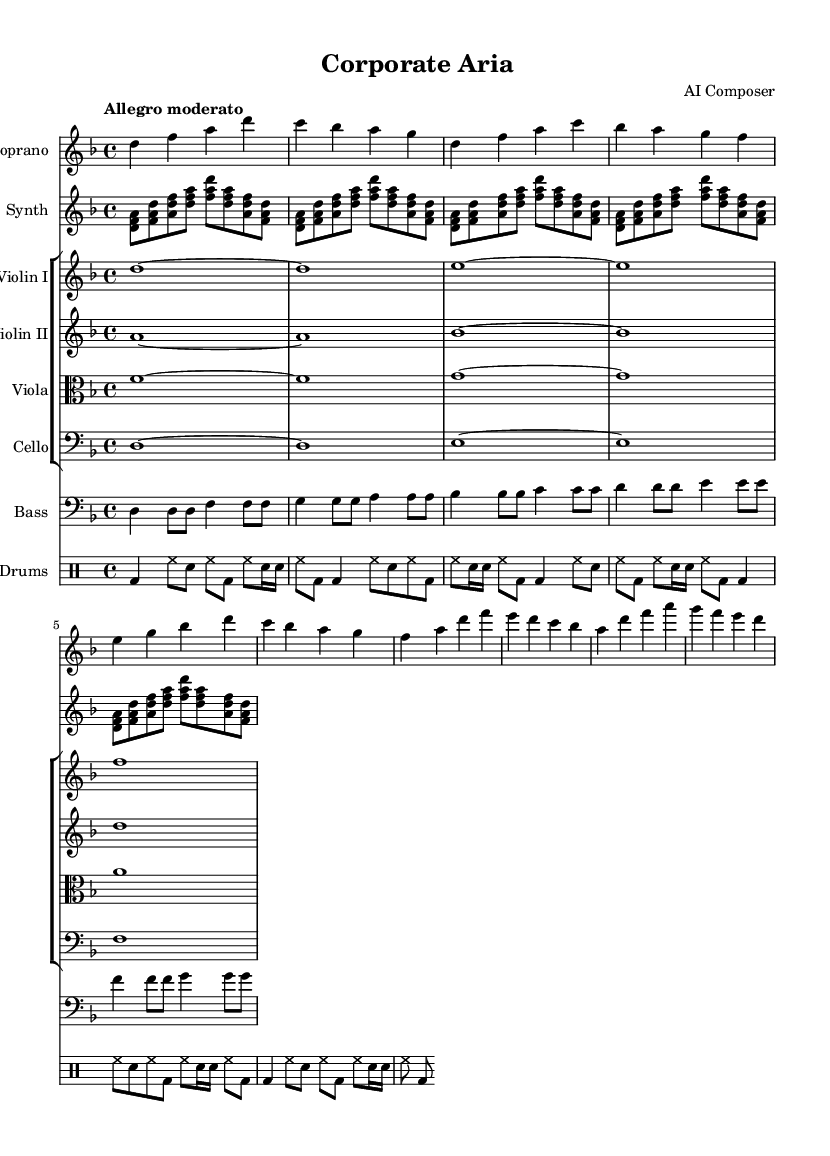What is the key signature of this music? The key signature shows two flats, indicating that the piece is in D minor. The presence of B-flat and E-flat confirms this.
Answer: D minor What is the time signature of the piece? The time signature is indicated at the beginning of the score, showing a four over four, which is common in many musical compositions. This means there are four beats in each measure.
Answer: 4/4 What is the tempo marking for this music? The tempo marking is written as "Allegro moderato," which suggests a moderate pace, typically ranging from 98 to 109 beats per minute.
Answer: Allegro moderato How many measures are there in the soprano part? The soprano part consists of a total of five measures, as indicated by the number of vertical lines separating the measures.
Answer: Five What instrumentation is featured in this piece? The score indicates multiple instruments: soprano, synth, two violins, viola, cello, bass, and drums, showcasing a blend of classical and electronic elements in Fusion opera.
Answer: Soprano, synth, violin I, violin II, viola, cello, bass, drums How does the electronic element integrate with classical instruments? The electronic synth plays rhythmic chords that support the melodic line of the soprano while interacting with traditional strings and percussion, suggesting a modern workplace dynamic within the opera's narrative.
Answer: Fusion of synth and strings What theme does the text of the aria convey? The lyrics illustrate modern workplace emotions and tensions, using imagery of glass, steel, and key strokes to reflect ambition and stress in a corporate environment.
Answer: Modern workplace dynamics 